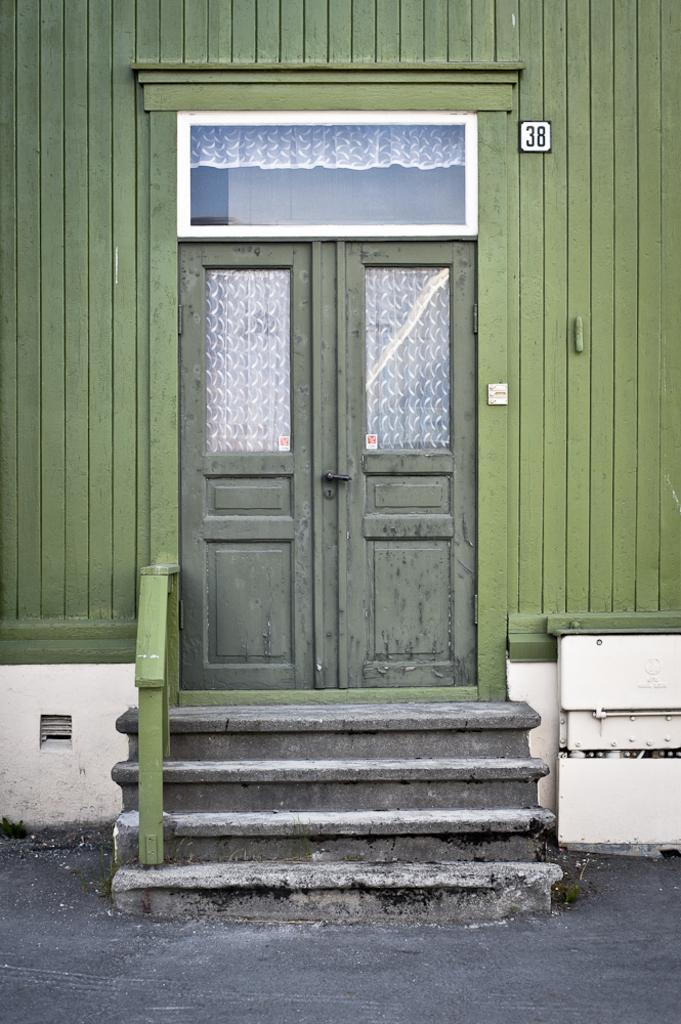What type of material is used for the wall in the image? The wall in the image is made of wood. Where is the door located in the image? The door is in the middle of the image. What architectural feature is present at the bottom of the image? There are steps at the bottom of the image. What type of teaching method is being demonstrated by the crow in the image? There is no crow present in the image, so no teaching method can be observed. What is the crow using to stir the pot in the image? There is no pot or crow present in the image, so no stirring can be observed. 